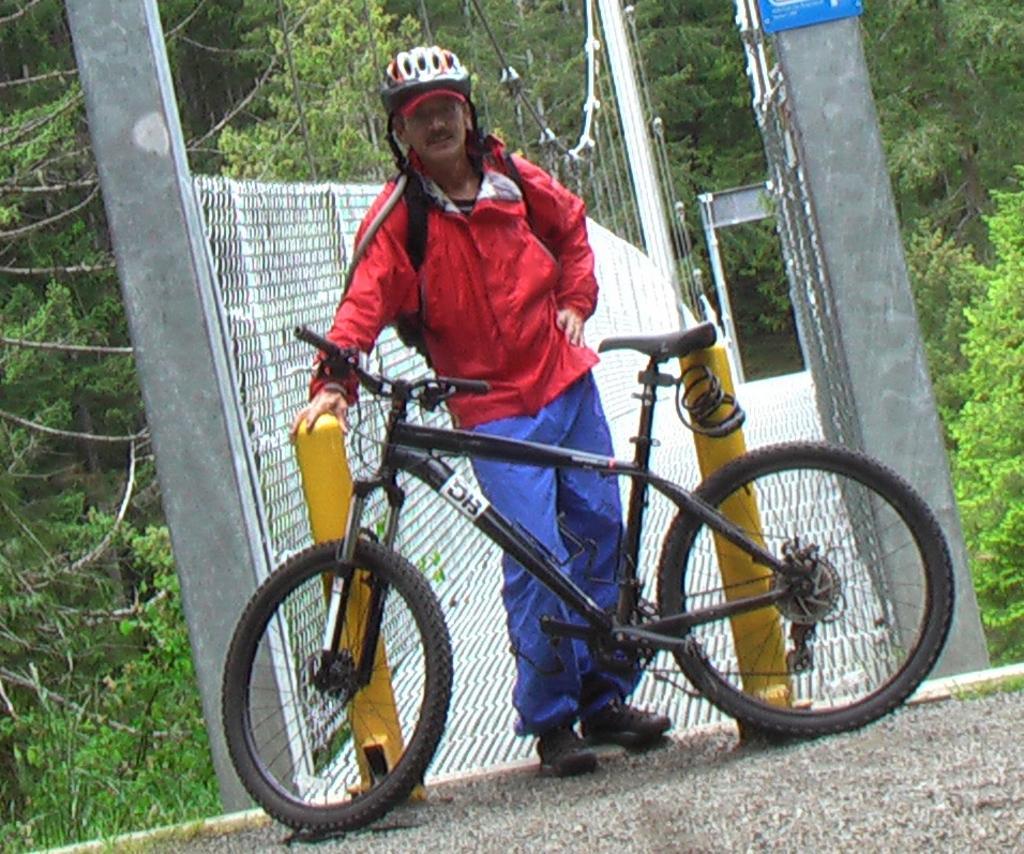Can you describe this image briefly? In this picture there is a man in the center of the image and there is a bicycles in front of him, there is a net boundary in the center of the image, behind the man and there are trees in the background area of the image. 